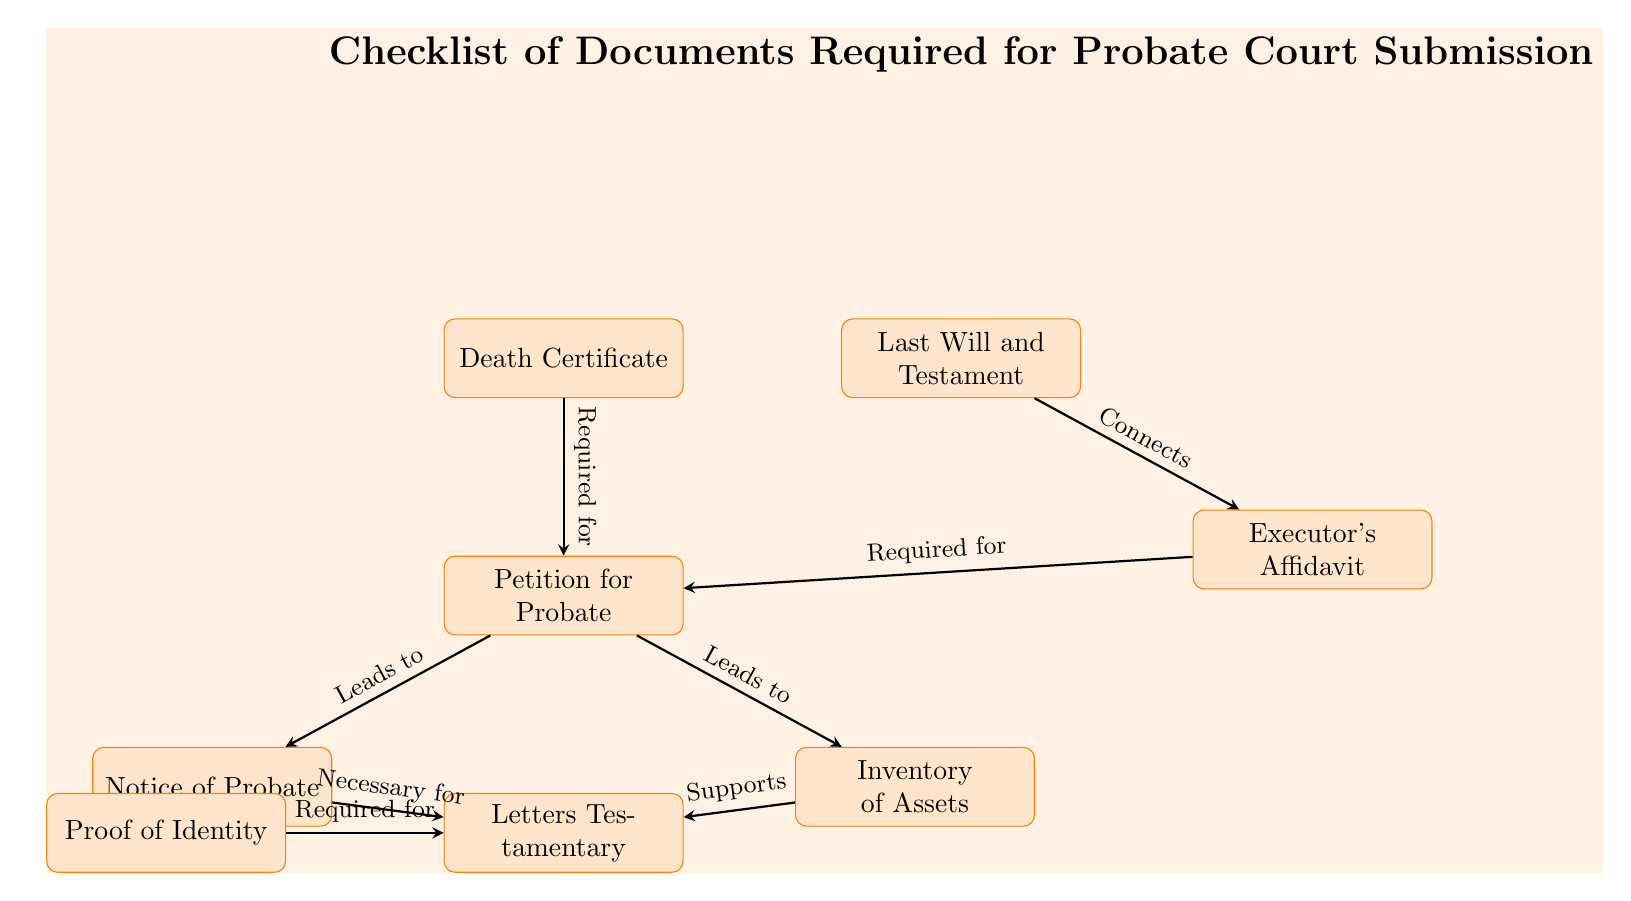What is the first document listed in the diagram? The diagram lists the Death Certificate as the first document, which is the starting point before submitting other documents for probate.
Answer: Death Certificate How many total documents are required for probate according to the diagram? There are a total of seven documents listed in the diagram: Death Certificate, Last Will and Testament, Executor's Affidavit, Petition for Probate, Notice of Probate, Inventory of Assets, and Letters Testamentary.
Answer: Seven Which document is necessary for the Letters Testamentary? According to the diagram, Proof of Identity is necessary for obtaining Letters Testamentary as indicated by the arrow pointing to it.
Answer: Proof of Identity What relationship does the Last Will and Testament have with the Executor's Affidavit? The diagram shows that the Last Will and Testament connects to the Executor's Affidavit, indicating that the Will is used to establish the Executor's claim.
Answer: Connects Which documents lead to the Notice of Probate? The diagram indicates that the Petition for Probate leads to the Notice of Probate, meaning the Petition is a necessary precursor to the Notice.
Answer: Petition for Probate How do Inventory of Assets and Notice of Probate relate to Letters Testamentary? The diagram shows that both the Inventory of Assets and the Notice of Probate support the issuance of Letters Testamentary, meaning they are required components in the process.
Answer: Supports What is the connection of the Executor's Affidavit to the Petition for Probate? In the diagram, the Executor's Affidavit is indicated as required for the Petition for Probate, establishing that the Affidavit must be included to complete this submission.
Answer: Required for Which document is not directly connected to the Death Certificate? The Last Will and Testament is not directly connected to the Death Certificate in the diagram, as it has its own path to the Executor's Affidavit.
Answer: Last Will and Testament 